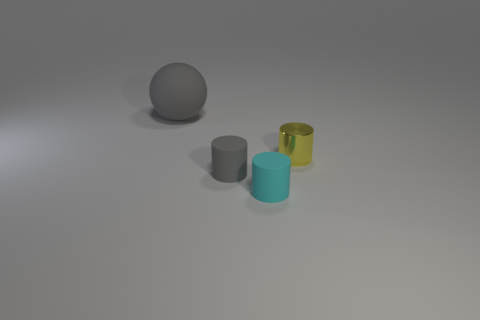Subtract all gray rubber cylinders. How many cylinders are left? 2 Add 1 small gray metal spheres. How many objects exist? 5 Subtract all cylinders. How many objects are left? 1 Add 1 cyan rubber cylinders. How many cyan rubber cylinders exist? 2 Subtract 0 blue balls. How many objects are left? 4 Subtract all blue cylinders. Subtract all large rubber objects. How many objects are left? 3 Add 1 big gray things. How many big gray things are left? 2 